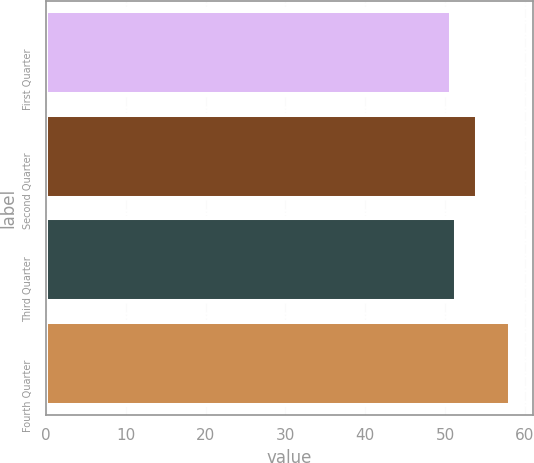<chart> <loc_0><loc_0><loc_500><loc_500><bar_chart><fcel>First Quarter<fcel>Second Quarter<fcel>Third Quarter<fcel>Fourth Quarter<nl><fcel>50.69<fcel>54.03<fcel>51.43<fcel>58.11<nl></chart> 